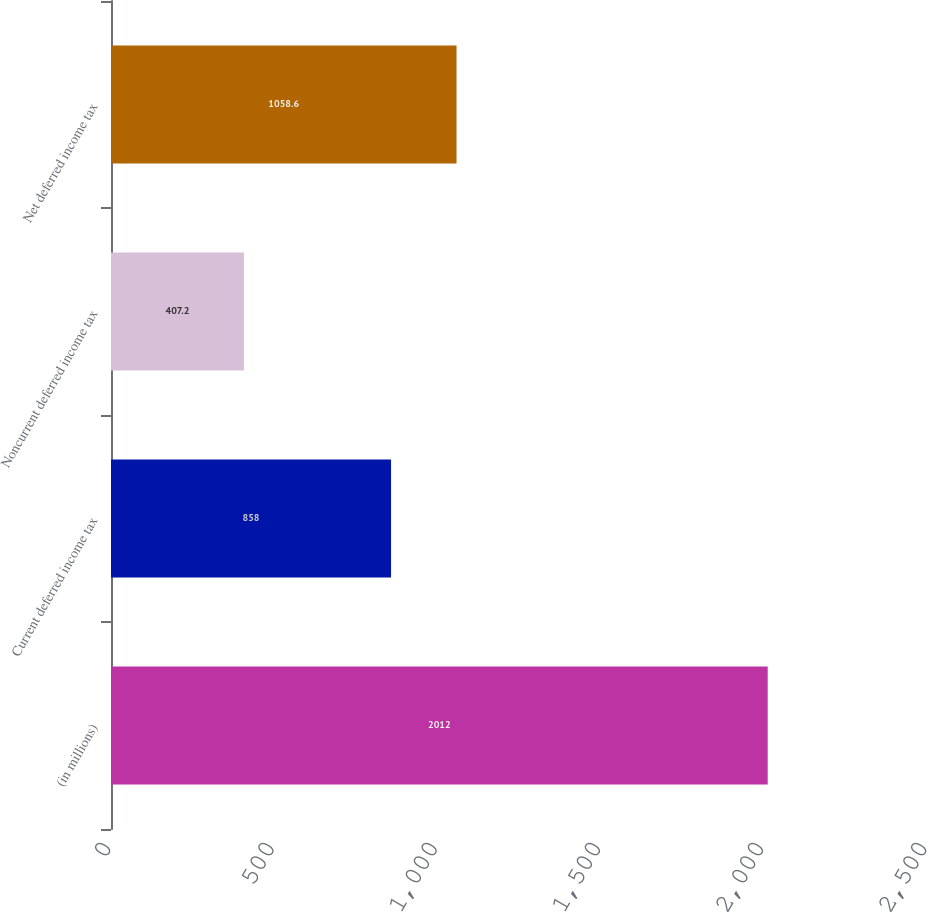Convert chart to OTSL. <chart><loc_0><loc_0><loc_500><loc_500><bar_chart><fcel>(in millions)<fcel>Current deferred income tax<fcel>Noncurrent deferred income tax<fcel>Net deferred income tax<nl><fcel>2012<fcel>858<fcel>407.2<fcel>1058.6<nl></chart> 